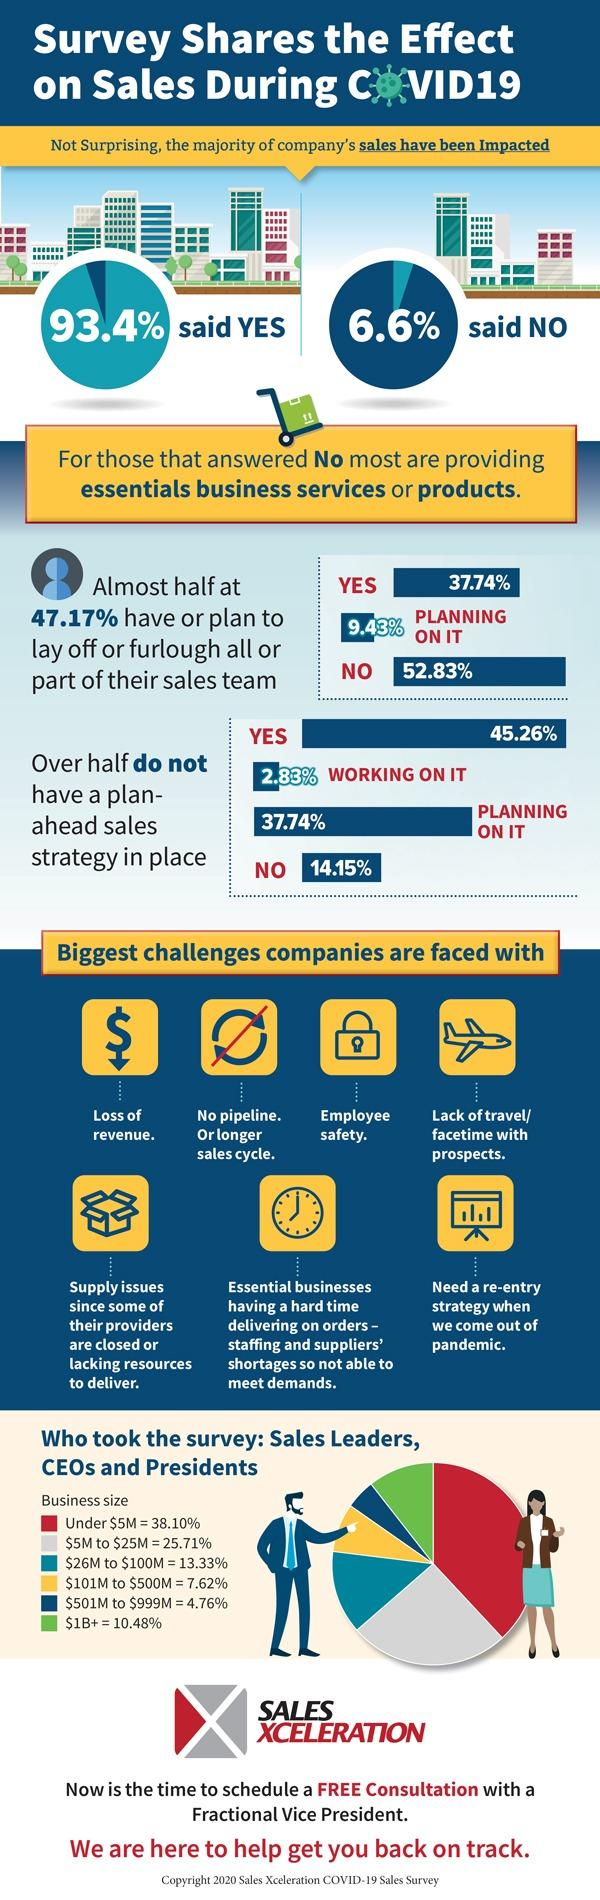Outline some significant characteristics in this image. Supply issues are depicted using a symbol of a bag and a box. The lack of travel is represented by both a car and a plane. Employee safety is depicted using the symbol of a lock, as a means to ensure the safety of employees in the workplace. 